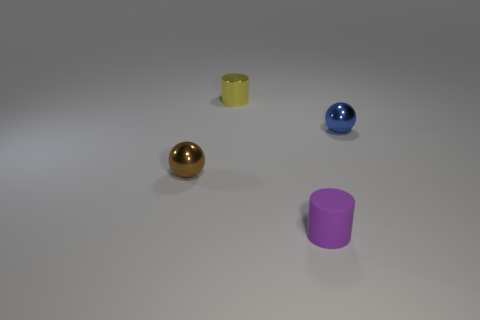What number of other objects are there of the same shape as the tiny blue thing?
Provide a short and direct response. 1. What is the color of the other ball that is made of the same material as the blue ball?
Offer a terse response. Brown. Is there a metal cylinder that has the same size as the yellow object?
Provide a succinct answer. No. Are there more tiny blue shiny spheres that are in front of the yellow shiny thing than cylinders that are to the right of the blue sphere?
Keep it short and to the point. Yes. Do the tiny cylinder that is behind the brown metal thing and the tiny cylinder that is on the right side of the tiny yellow thing have the same material?
Offer a terse response. No. There is a brown object that is the same size as the metal cylinder; what shape is it?
Your response must be concise. Sphere. Is there another tiny thing that has the same shape as the tiny purple rubber thing?
Offer a very short reply. Yes. There is a tiny brown metal ball; are there any tiny blue metallic objects in front of it?
Your answer should be compact. No. There is a thing that is both on the left side of the blue thing and right of the tiny metal cylinder; what material is it?
Offer a very short reply. Rubber. Does the cylinder on the left side of the purple matte cylinder have the same material as the small blue sphere?
Offer a terse response. Yes. 